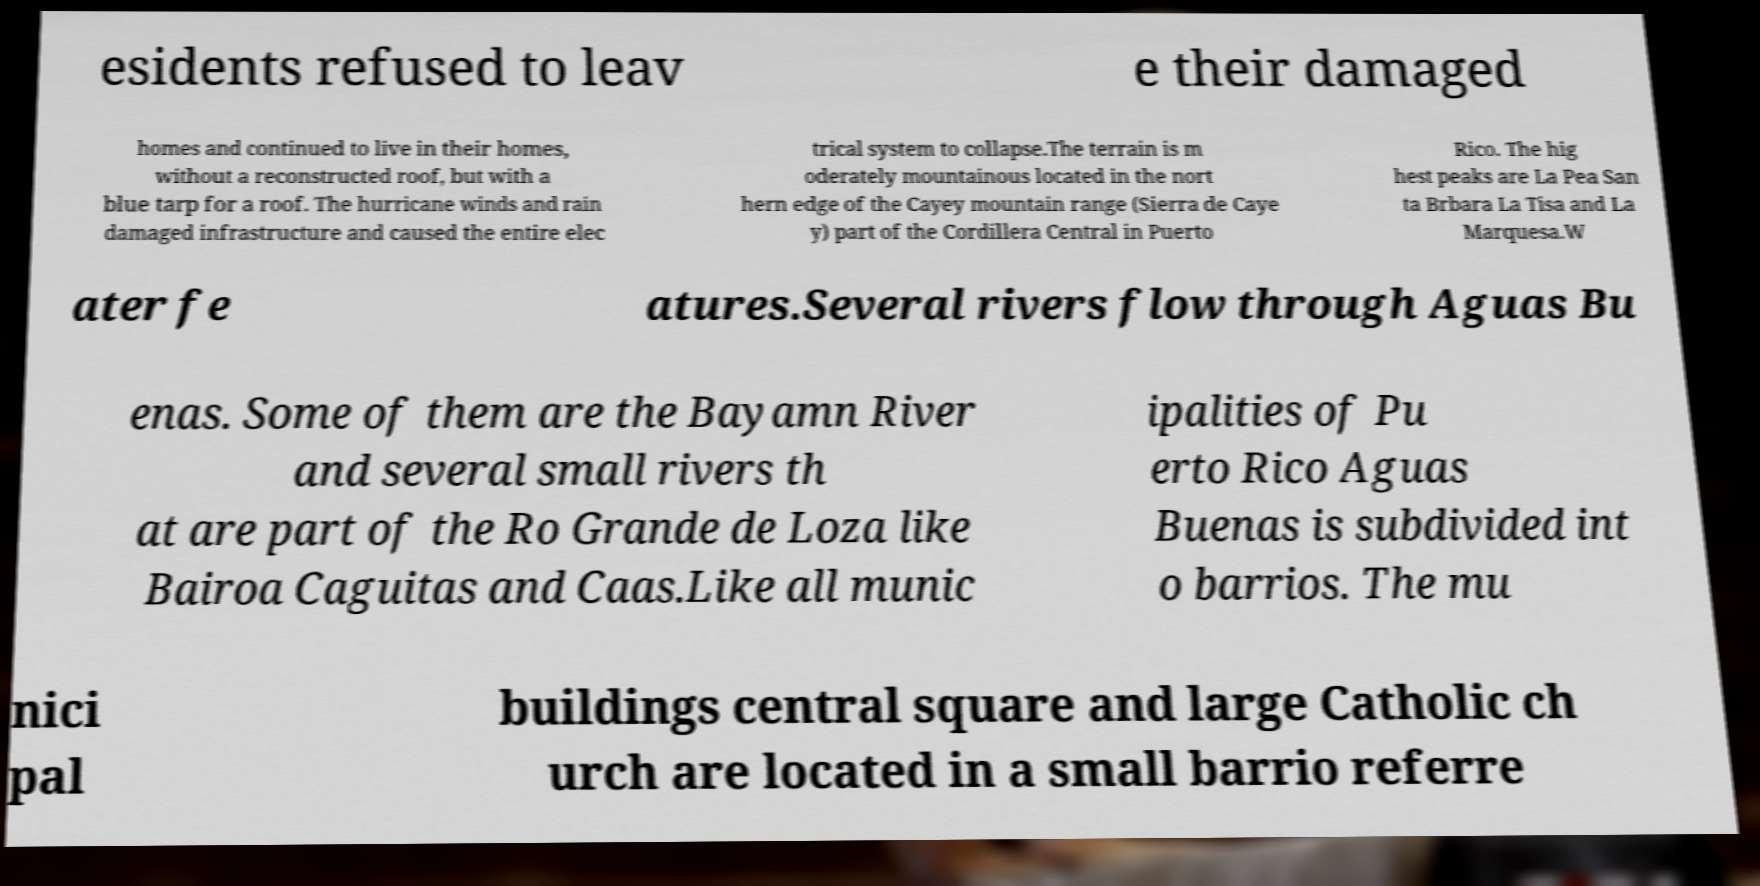What messages or text are displayed in this image? I need them in a readable, typed format. esidents refused to leav e their damaged homes and continued to live in their homes, without a reconstructed roof, but with a blue tarp for a roof. The hurricane winds and rain damaged infrastructure and caused the entire elec trical system to collapse.The terrain is m oderately mountainous located in the nort hern edge of the Cayey mountain range (Sierra de Caye y) part of the Cordillera Central in Puerto Rico. The hig hest peaks are La Pea San ta Brbara La Tisa and La Marquesa.W ater fe atures.Several rivers flow through Aguas Bu enas. Some of them are the Bayamn River and several small rivers th at are part of the Ro Grande de Loza like Bairoa Caguitas and Caas.Like all munic ipalities of Pu erto Rico Aguas Buenas is subdivided int o barrios. The mu nici pal buildings central square and large Catholic ch urch are located in a small barrio referre 